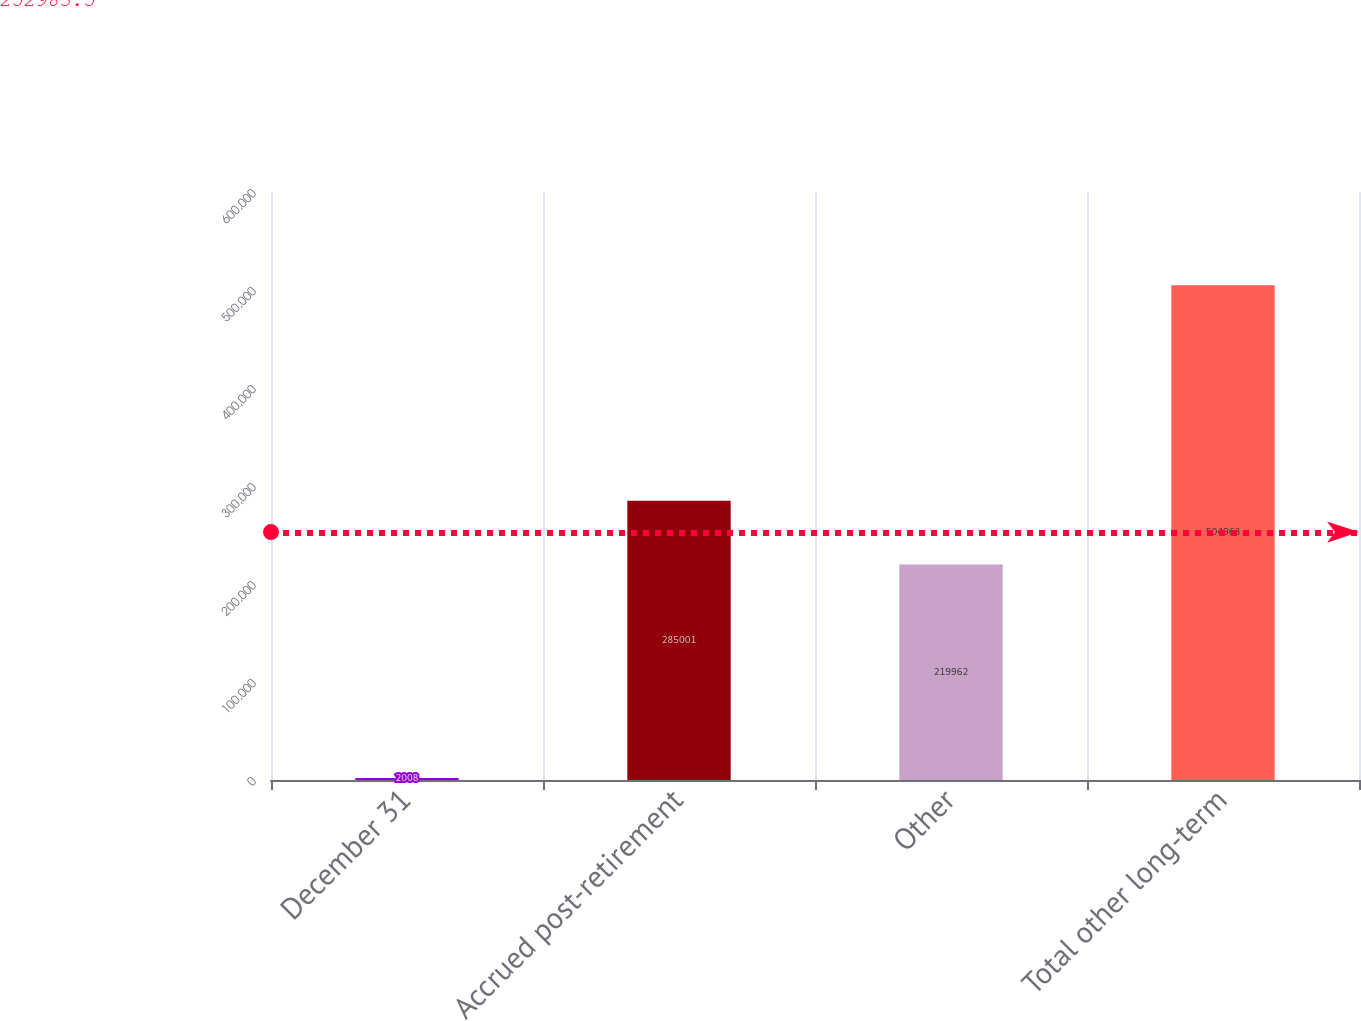<chart> <loc_0><loc_0><loc_500><loc_500><bar_chart><fcel>December 31<fcel>Accrued post-retirement<fcel>Other<fcel>Total other long-term<nl><fcel>2008<fcel>285001<fcel>219962<fcel>504963<nl></chart> 